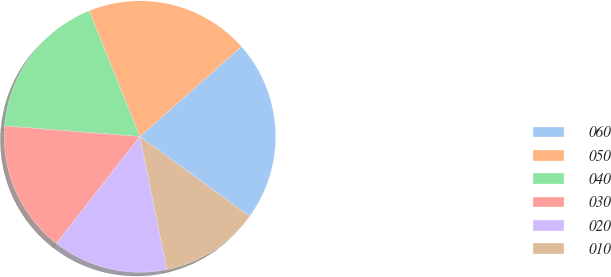Convert chart. <chart><loc_0><loc_0><loc_500><loc_500><pie_chart><fcel>060<fcel>050<fcel>040<fcel>030<fcel>020<fcel>010<nl><fcel>21.55%<fcel>19.59%<fcel>17.64%<fcel>15.69%<fcel>13.74%<fcel>11.79%<nl></chart> 